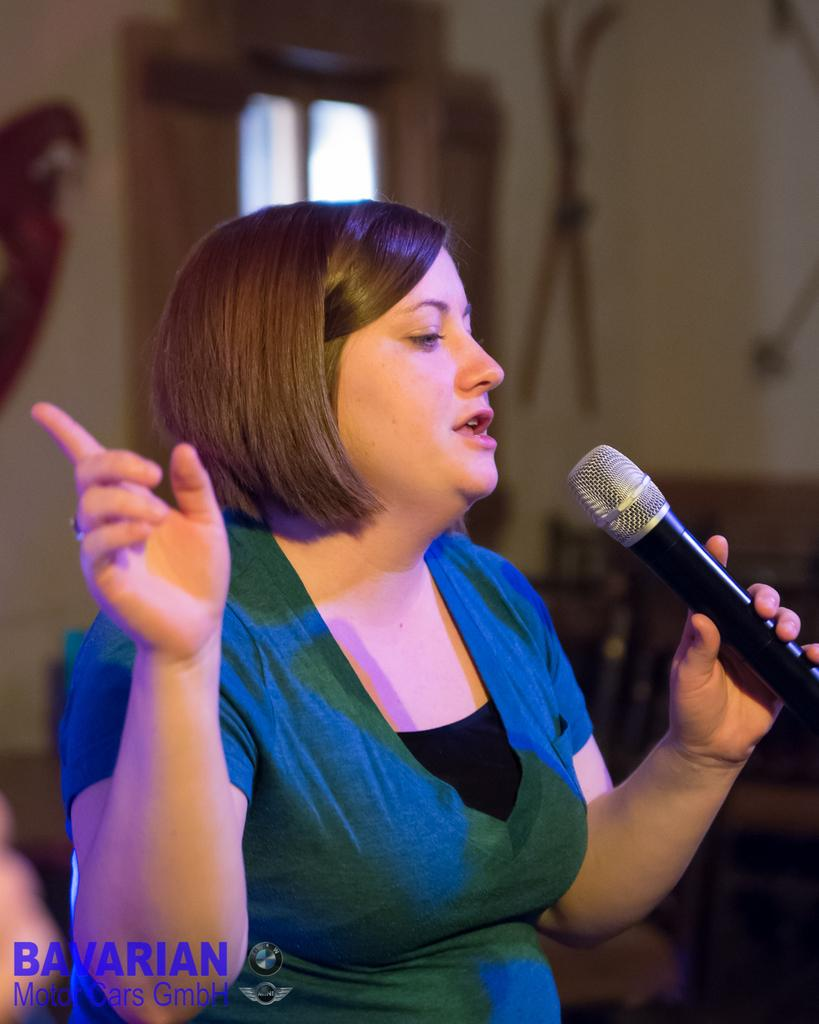What is the main subject of the image? The main subject of the image is a woman. What is the woman holding in the image? The woman is holding a mic. What color is the dress the woman is wearing? The woman is wearing a blue dress. How is the background of the woman depicted in the image? The background of the woman is blurred. What type of rake is the woman using to answer questions in the image? There is no rake present in the image, and the woman is not answering questions. 